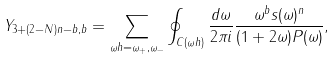<formula> <loc_0><loc_0><loc_500><loc_500>Y _ { 3 + ( 2 - N ) n - b , b } = \sum _ { \omega h = \omega _ { + } , \omega _ { - } } \oint _ { C ( \omega h ) } \frac { d \omega } { 2 \pi i } \frac { \omega ^ { b } s ( \omega ) ^ { n } } { ( 1 + 2 \omega ) P ( \omega ) } ,</formula> 